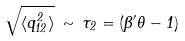Convert formula to latex. <formula><loc_0><loc_0><loc_500><loc_500>\sqrt { \langle q _ { 1 2 } ^ { 2 } \rangle } \, \sim \, \tau _ { 2 } = ( \beta ^ { \prime } \theta - 1 )</formula> 